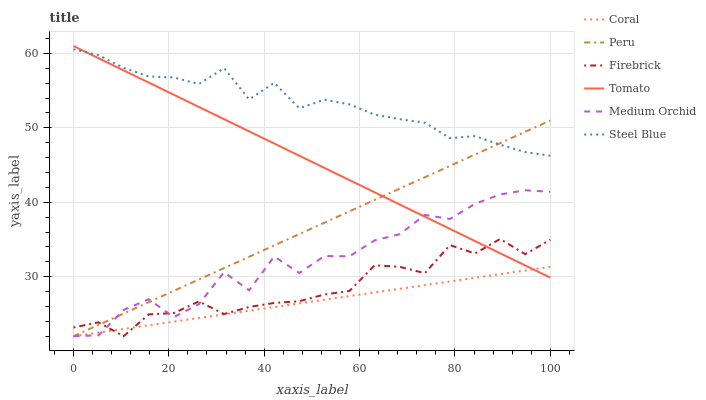Does Coral have the minimum area under the curve?
Answer yes or no. Yes. Does Steel Blue have the maximum area under the curve?
Answer yes or no. Yes. Does Medium Orchid have the minimum area under the curve?
Answer yes or no. No. Does Medium Orchid have the maximum area under the curve?
Answer yes or no. No. Is Coral the smoothest?
Answer yes or no. Yes. Is Medium Orchid the roughest?
Answer yes or no. Yes. Is Medium Orchid the smoothest?
Answer yes or no. No. Is Coral the roughest?
Answer yes or no. No. Does Coral have the lowest value?
Answer yes or no. Yes. Does Steel Blue have the lowest value?
Answer yes or no. No. Does Tomato have the highest value?
Answer yes or no. Yes. Does Medium Orchid have the highest value?
Answer yes or no. No. Is Coral less than Steel Blue?
Answer yes or no. Yes. Is Steel Blue greater than Coral?
Answer yes or no. Yes. Does Tomato intersect Medium Orchid?
Answer yes or no. Yes. Is Tomato less than Medium Orchid?
Answer yes or no. No. Is Tomato greater than Medium Orchid?
Answer yes or no. No. Does Coral intersect Steel Blue?
Answer yes or no. No. 